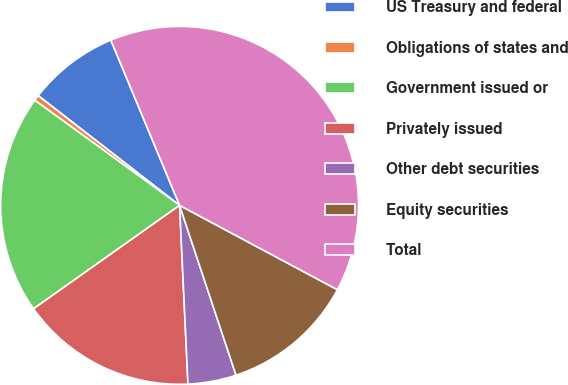<chart> <loc_0><loc_0><loc_500><loc_500><pie_chart><fcel>US Treasury and federal<fcel>Obligations of states and<fcel>Government issued or<fcel>Privately issued<fcel>Other debt securities<fcel>Equity securities<fcel>Total<nl><fcel>8.22%<fcel>0.51%<fcel>19.8%<fcel>15.94%<fcel>4.36%<fcel>12.08%<fcel>39.09%<nl></chart> 